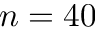Convert formula to latex. <formula><loc_0><loc_0><loc_500><loc_500>n = 4 0</formula> 